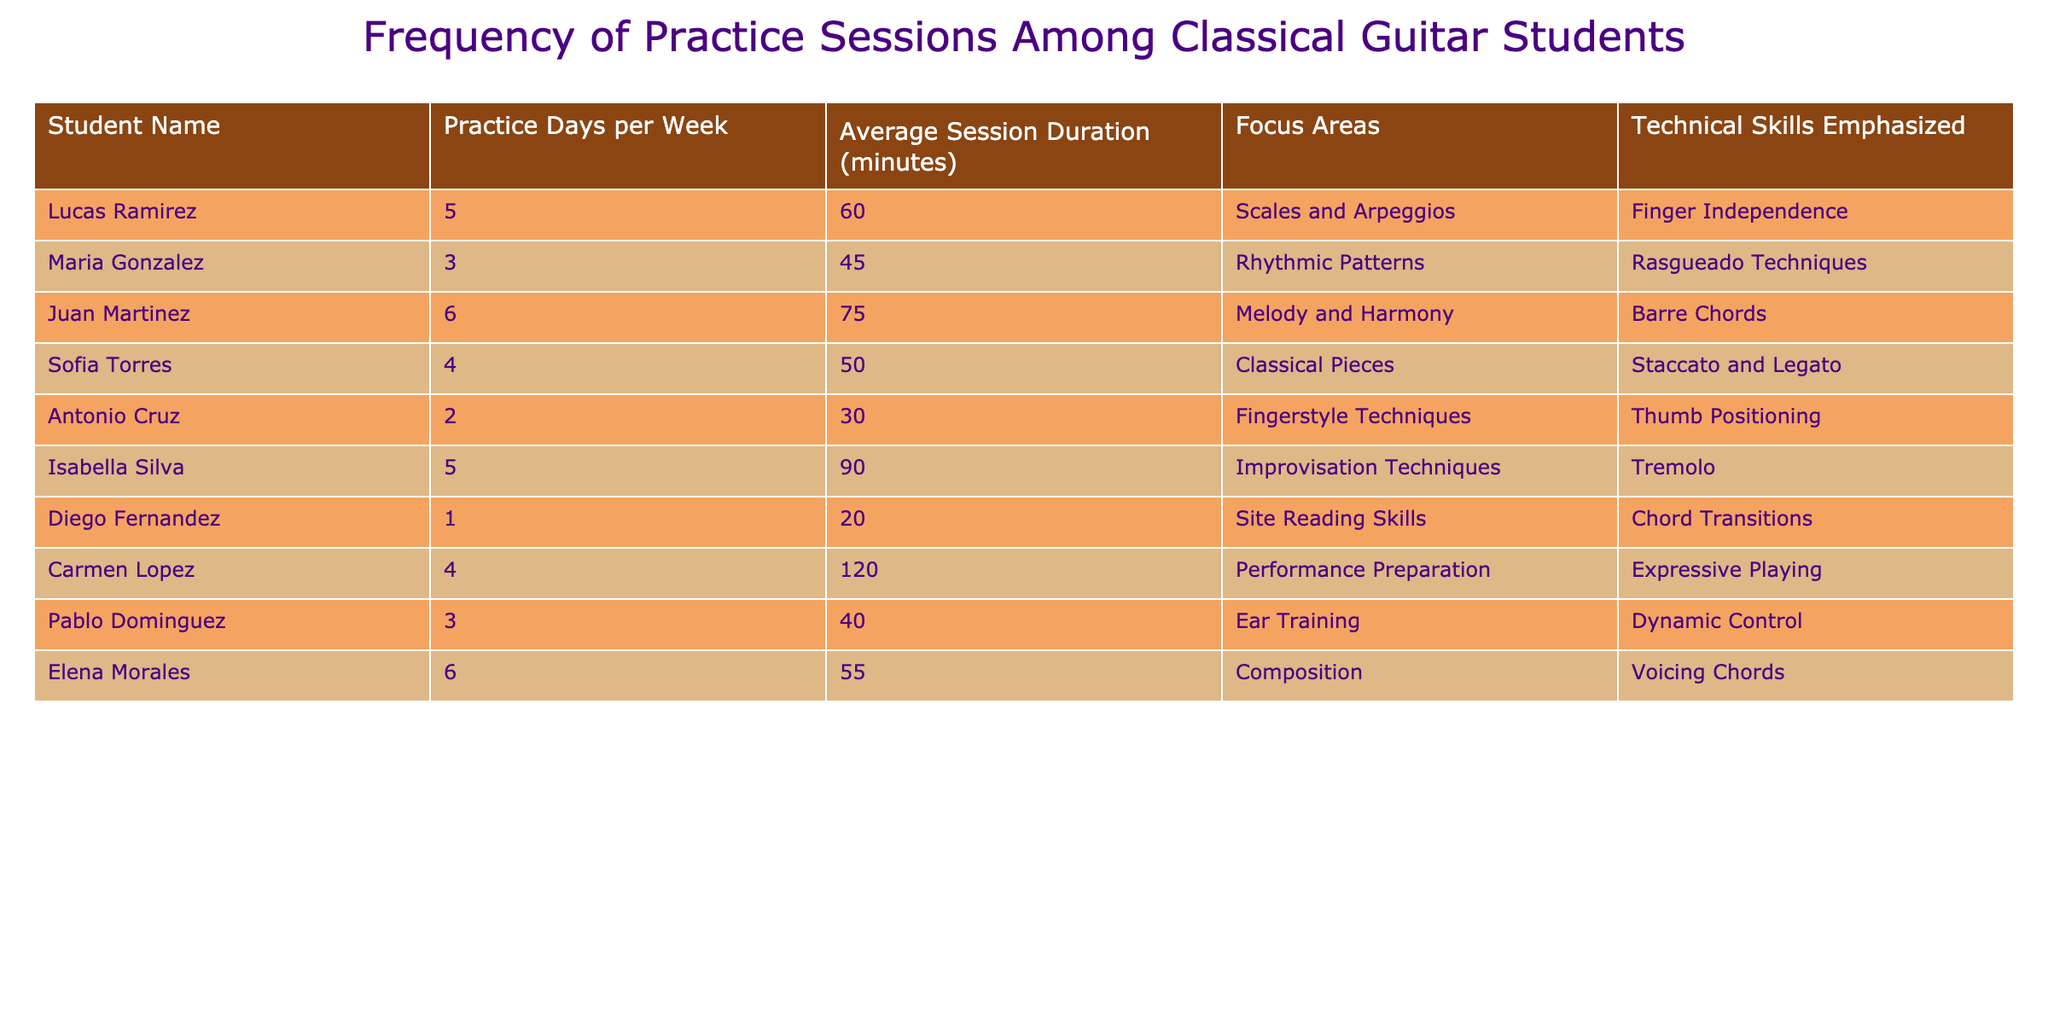What is the average session duration for the students who practice five days a week? The students who practice five days a week are Lucas Ramirez and Isabella Silva with session durations of 60 and 90 minutes, respectively. We sum these values: 60 + 90 = 150 minutes. There are 2 students, so we calculate the average: 150/2 = 75 minutes.
Answer: 75 minutes Which student has the most practice days per week? Juan Martinez practices 6 days per week, which is the highest value in the 'Practice Days per Week' column.
Answer: Juan Martinez Is there a student who practices only one day a week? Yes, Diego Fernandez practices only one day a week, as indicated by the entry in the table.
Answer: Yes What is the total average session duration for all students? We sum all the session durations: 60 + 45 + 75 + 50 + 30 + 90 + 20 + 120 + 40 + 55 = 525 minutes. There are 10 students, so the average is: 525/10 = 52.5 minutes.
Answer: 52.5 minutes Which focus area is practiced by the most students? The focus areas are: Scales and Arpeggios (1), Rhythmic Patterns (1), Melody and Harmony (1), Classical Pieces (1), Fingerstyle Techniques (1), Improvisation Techniques (1), Site Reading Skills (1), Performance Preparation (1), Ear Training (1), Composition (1). All focus areas are represented by only one student each; therefore, none are practiced by more than one student.
Answer: None What percentage of students emphasize "Barre Chords" as a technical skill? Only Juan Martinez emphasizes "Barre Chords," which is 1 out of 10 students. Therefore, the percentage is calculated as (1/10) * 100 = 10%.
Answer: 10% Which student has the longest average session duration? Isabella Silva has the longest average session duration of 90 minutes, based on the 'Average Session Duration (minutes)' column in the table.
Answer: Isabella Silva Do more students practice classical pieces than improvisation techniques? There are 2 students focusing on classical pieces (Sofia Torres) and 1 on improvisation techniques (Isabella Silva). Therefore, more students practice classical pieces.
Answer: Yes What is the total number of practice days for students who focus on performance preparation and expressive playing? Only Carmen Lopez focuses on performance preparation. She practices 4 days per week. Thus, the total number of practice days for this focus area is 4.
Answer: 4 